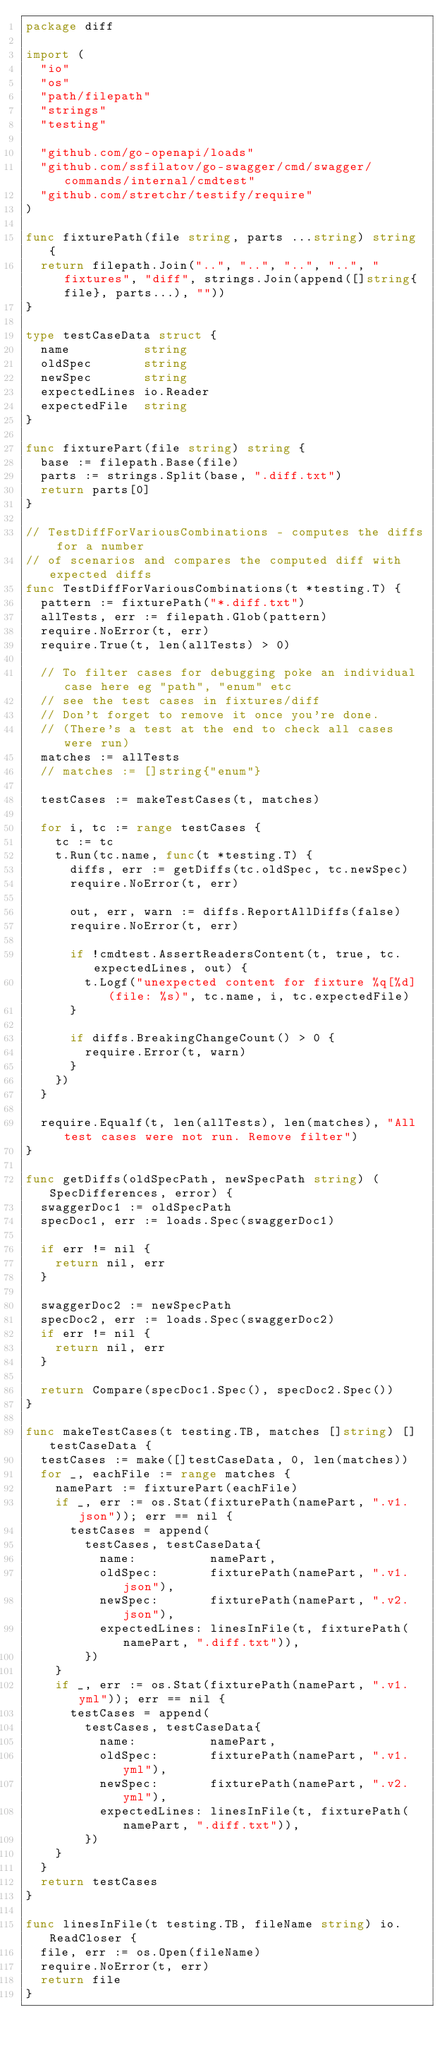Convert code to text. <code><loc_0><loc_0><loc_500><loc_500><_Go_>package diff

import (
	"io"
	"os"
	"path/filepath"
	"strings"
	"testing"

	"github.com/go-openapi/loads"
	"github.com/ssfilatov/go-swagger/cmd/swagger/commands/internal/cmdtest"
	"github.com/stretchr/testify/require"
)

func fixturePath(file string, parts ...string) string {
	return filepath.Join("..", "..", "..", "..", "fixtures", "diff", strings.Join(append([]string{file}, parts...), ""))
}

type testCaseData struct {
	name          string
	oldSpec       string
	newSpec       string
	expectedLines io.Reader
	expectedFile  string
}

func fixturePart(file string) string {
	base := filepath.Base(file)
	parts := strings.Split(base, ".diff.txt")
	return parts[0]
}

// TestDiffForVariousCombinations - computes the diffs for a number
// of scenarios and compares the computed diff with expected diffs
func TestDiffForVariousCombinations(t *testing.T) {
	pattern := fixturePath("*.diff.txt")
	allTests, err := filepath.Glob(pattern)
	require.NoError(t, err)
	require.True(t, len(allTests) > 0)

	// To filter cases for debugging poke an individual case here eg "path", "enum" etc
	// see the test cases in fixtures/diff
	// Don't forget to remove it once you're done.
	// (There's a test at the end to check all cases were run)
	matches := allTests
	// matches := []string{"enum"}

	testCases := makeTestCases(t, matches)

	for i, tc := range testCases {
		tc := tc
		t.Run(tc.name, func(t *testing.T) {
			diffs, err := getDiffs(tc.oldSpec, tc.newSpec)
			require.NoError(t, err)

			out, err, warn := diffs.ReportAllDiffs(false)
			require.NoError(t, err)

			if !cmdtest.AssertReadersContent(t, true, tc.expectedLines, out) {
				t.Logf("unexpected content for fixture %q[%d] (file: %s)", tc.name, i, tc.expectedFile)
			}

			if diffs.BreakingChangeCount() > 0 {
				require.Error(t, warn)
			}
		})
	}

	require.Equalf(t, len(allTests), len(matches), "All test cases were not run. Remove filter")
}

func getDiffs(oldSpecPath, newSpecPath string) (SpecDifferences, error) {
	swaggerDoc1 := oldSpecPath
	specDoc1, err := loads.Spec(swaggerDoc1)

	if err != nil {
		return nil, err
	}

	swaggerDoc2 := newSpecPath
	specDoc2, err := loads.Spec(swaggerDoc2)
	if err != nil {
		return nil, err
	}

	return Compare(specDoc1.Spec(), specDoc2.Spec())
}

func makeTestCases(t testing.TB, matches []string) []testCaseData {
	testCases := make([]testCaseData, 0, len(matches))
	for _, eachFile := range matches {
		namePart := fixturePart(eachFile)
		if _, err := os.Stat(fixturePath(namePart, ".v1.json")); err == nil {
			testCases = append(
				testCases, testCaseData{
					name:          namePart,
					oldSpec:       fixturePath(namePart, ".v1.json"),
					newSpec:       fixturePath(namePart, ".v2.json"),
					expectedLines: linesInFile(t, fixturePath(namePart, ".diff.txt")),
				})
		}
		if _, err := os.Stat(fixturePath(namePart, ".v1.yml")); err == nil {
			testCases = append(
				testCases, testCaseData{
					name:          namePart,
					oldSpec:       fixturePath(namePart, ".v1.yml"),
					newSpec:       fixturePath(namePart, ".v2.yml"),
					expectedLines: linesInFile(t, fixturePath(namePart, ".diff.txt")),
				})
		}
	}
	return testCases
}

func linesInFile(t testing.TB, fileName string) io.ReadCloser {
	file, err := os.Open(fileName)
	require.NoError(t, err)
	return file
}
</code> 